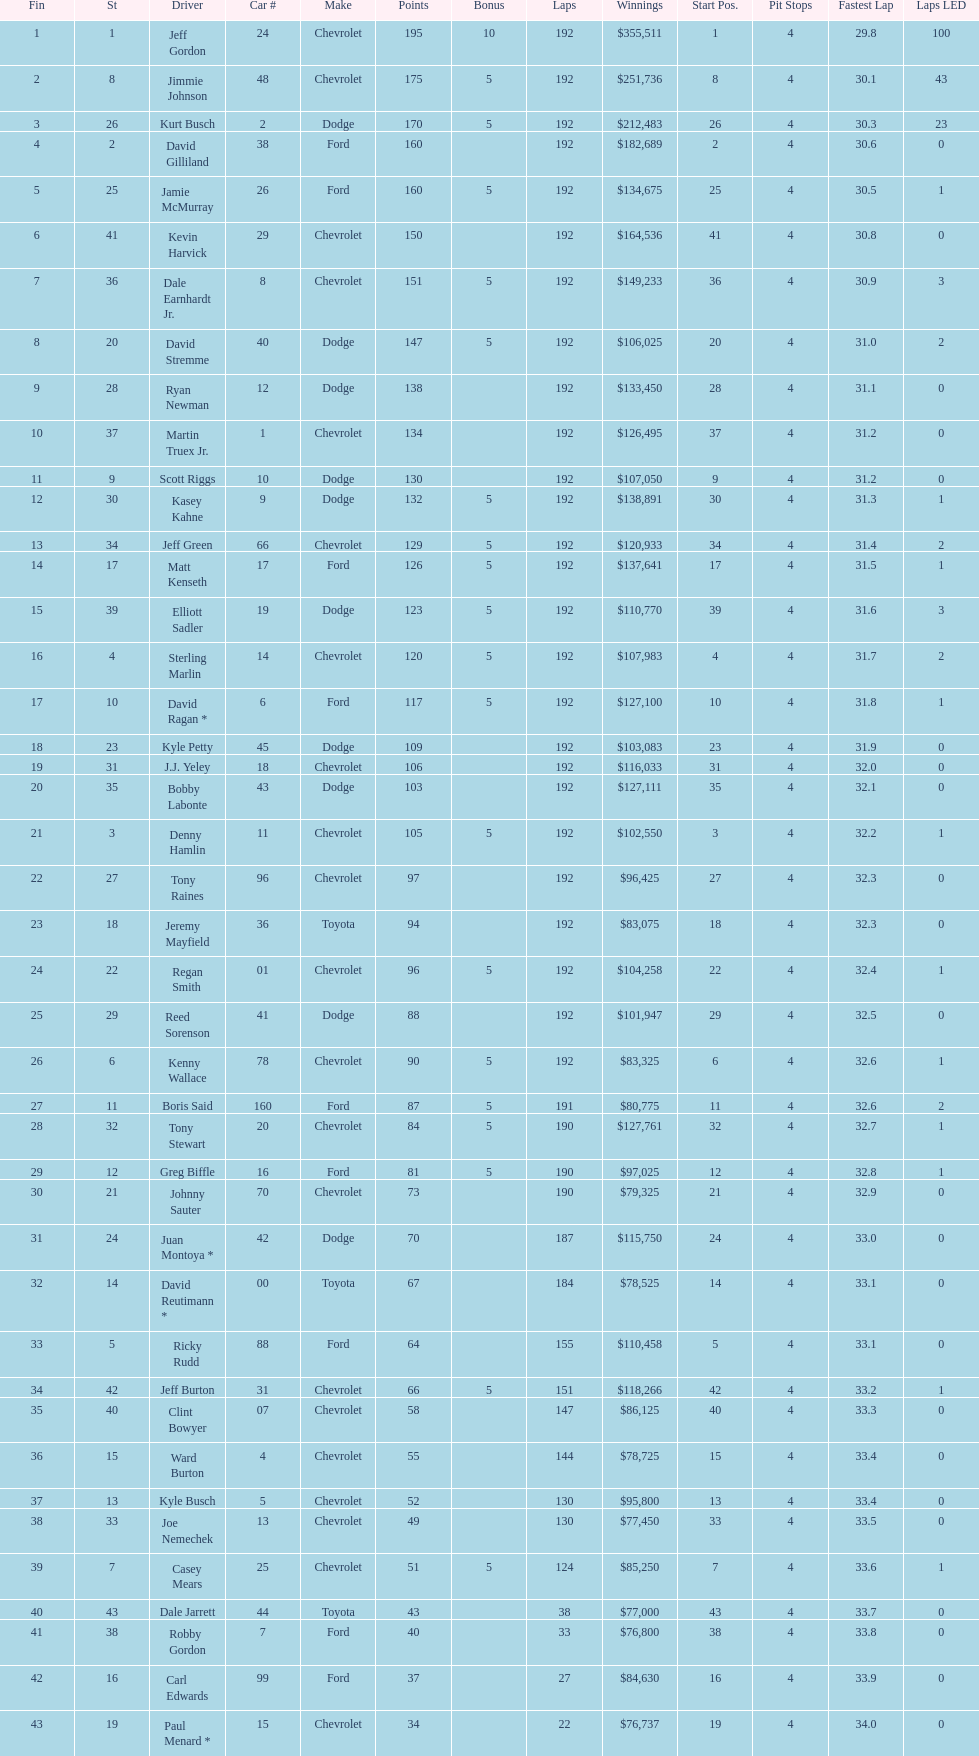What was jimmie johnson's winnings? $251,736. 